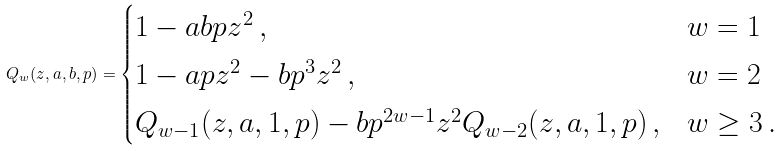Convert formula to latex. <formula><loc_0><loc_0><loc_500><loc_500>Q _ { w } ( z , a , b , p ) = \begin{cases} 1 - a b p z ^ { 2 } \, , & w = 1 \\ 1 - a p z ^ { 2 } - b p ^ { 3 } z ^ { 2 } \, , & w = 2 \\ Q _ { w - 1 } ( z , a , 1 , p ) - b p ^ { 2 w - 1 } z ^ { 2 } Q _ { w - 2 } ( z , a , 1 , p ) \, , & w \geq 3 \, . \end{cases}</formula> 